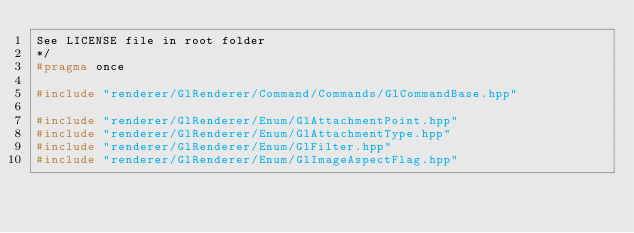<code> <loc_0><loc_0><loc_500><loc_500><_C++_>See LICENSE file in root folder
*/
#pragma once

#include "renderer/GlRenderer/Command/Commands/GlCommandBase.hpp"

#include "renderer/GlRenderer/Enum/GlAttachmentPoint.hpp"
#include "renderer/GlRenderer/Enum/GlAttachmentType.hpp"
#include "renderer/GlRenderer/Enum/GlFilter.hpp"
#include "renderer/GlRenderer/Enum/GlImageAspectFlag.hpp"
</code> 